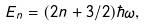<formula> <loc_0><loc_0><loc_500><loc_500>E _ { n } = ( 2 n + 3 / 2 ) \hbar { \omega } ,</formula> 